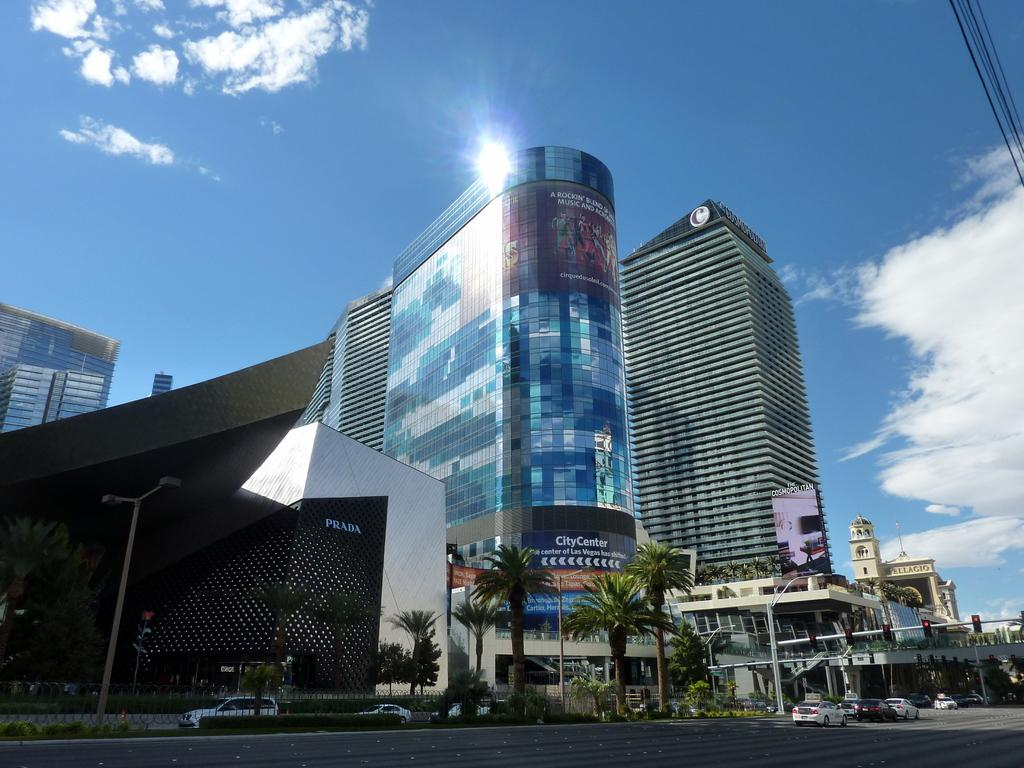<image>
Create a compact narrative representing the image presented. A Prada store and a large building with a banner for Los Vegas city center. 